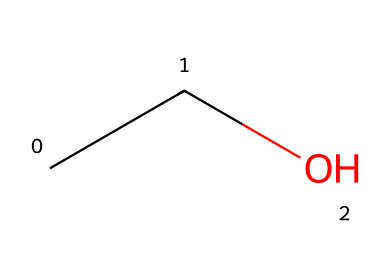How many carbon atoms are in ethanol? The SMILES representation 'CCO' indicates two carbon (C) atoms, as each 'C' represents a carbon atom in a chain.
Answer: 2 What is the functional group present in ethanol? Ethanol has a hydroxyl group (-OH) attached to the second carbon, which classifies it as an alcohol. This functional group determines its chemical properties.
Answer: hydroxyl What is the total number of hydrogen atoms in ethanol? In the SMILES representation, the two carbon atoms have connected hydrogen atoms. Each carbon is bonded to three and two hydrogen atoms, respectively, resulting in a total of six hydrogen atoms.
Answer: 6 Is ethanol a saturated or unsaturated compound? Ethanol, represented as 'CCO,' shows that it does not have any double or triple bonds between the carbon atoms, making it a saturated compound.
Answer: saturated What type of compound is ethanol classified as? Ethanol contains carbon and hydrogen, along with a hydroxyl functional group, placing it in the category of aliphatic compounds, specifically alcohols.
Answer: alcohol What is the molecular formula of ethanol based on its structure? Analyzing the SMILES 'CCO,' we see it contains 2 carbon atoms, 6 hydrogen atoms, and 1 oxygen atom. Thus, the molecular formula, which combines these is C2H6O.
Answer: C2H6O 